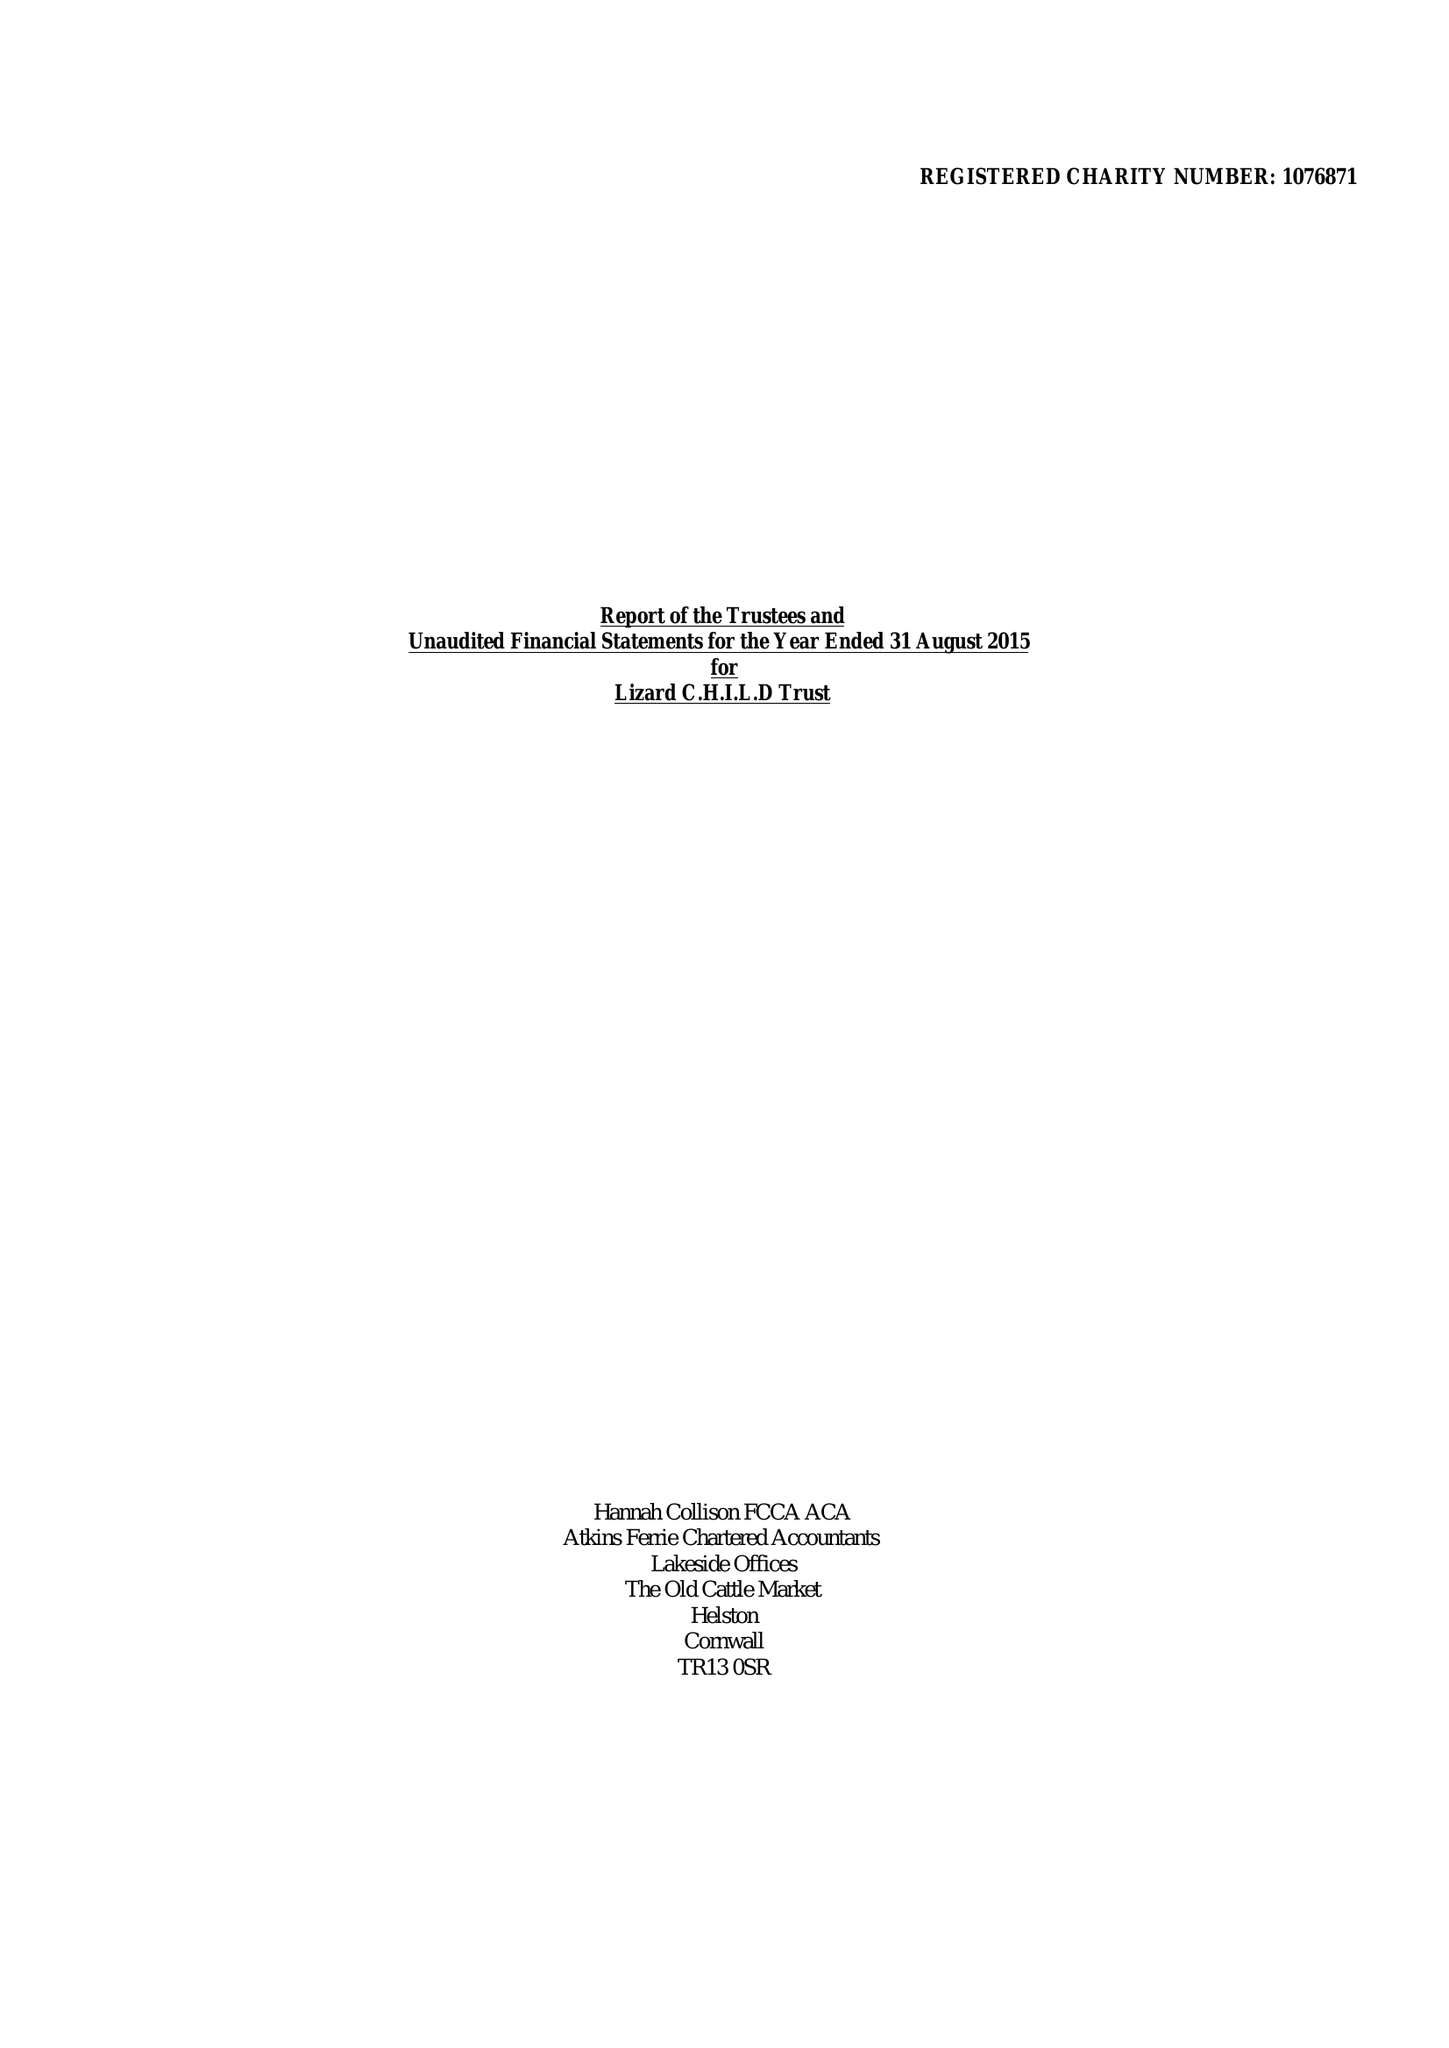What is the value for the income_annually_in_british_pounds?
Answer the question using a single word or phrase. 265386.00 